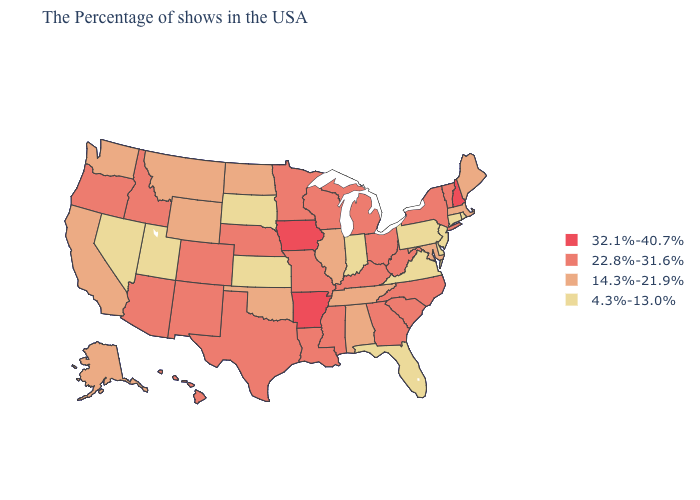What is the highest value in the Northeast ?
Write a very short answer. 32.1%-40.7%. Name the states that have a value in the range 4.3%-13.0%?
Answer briefly. Rhode Island, Connecticut, New Jersey, Delaware, Pennsylvania, Virginia, Florida, Indiana, Kansas, South Dakota, Utah, Nevada. What is the value of Indiana?
Concise answer only. 4.3%-13.0%. Does Massachusetts have a higher value than Ohio?
Concise answer only. No. Does Idaho have the highest value in the West?
Concise answer only. Yes. Does Iowa have the highest value in the MidWest?
Give a very brief answer. Yes. Does the first symbol in the legend represent the smallest category?
Short answer required. No. What is the value of Idaho?
Write a very short answer. 22.8%-31.6%. What is the highest value in the USA?
Keep it brief. 32.1%-40.7%. Does Georgia have a higher value than New Mexico?
Write a very short answer. No. Is the legend a continuous bar?
Concise answer only. No. What is the highest value in the USA?
Short answer required. 32.1%-40.7%. Does the map have missing data?
Be succinct. No. Name the states that have a value in the range 4.3%-13.0%?
Keep it brief. Rhode Island, Connecticut, New Jersey, Delaware, Pennsylvania, Virginia, Florida, Indiana, Kansas, South Dakota, Utah, Nevada. What is the highest value in the USA?
Give a very brief answer. 32.1%-40.7%. 